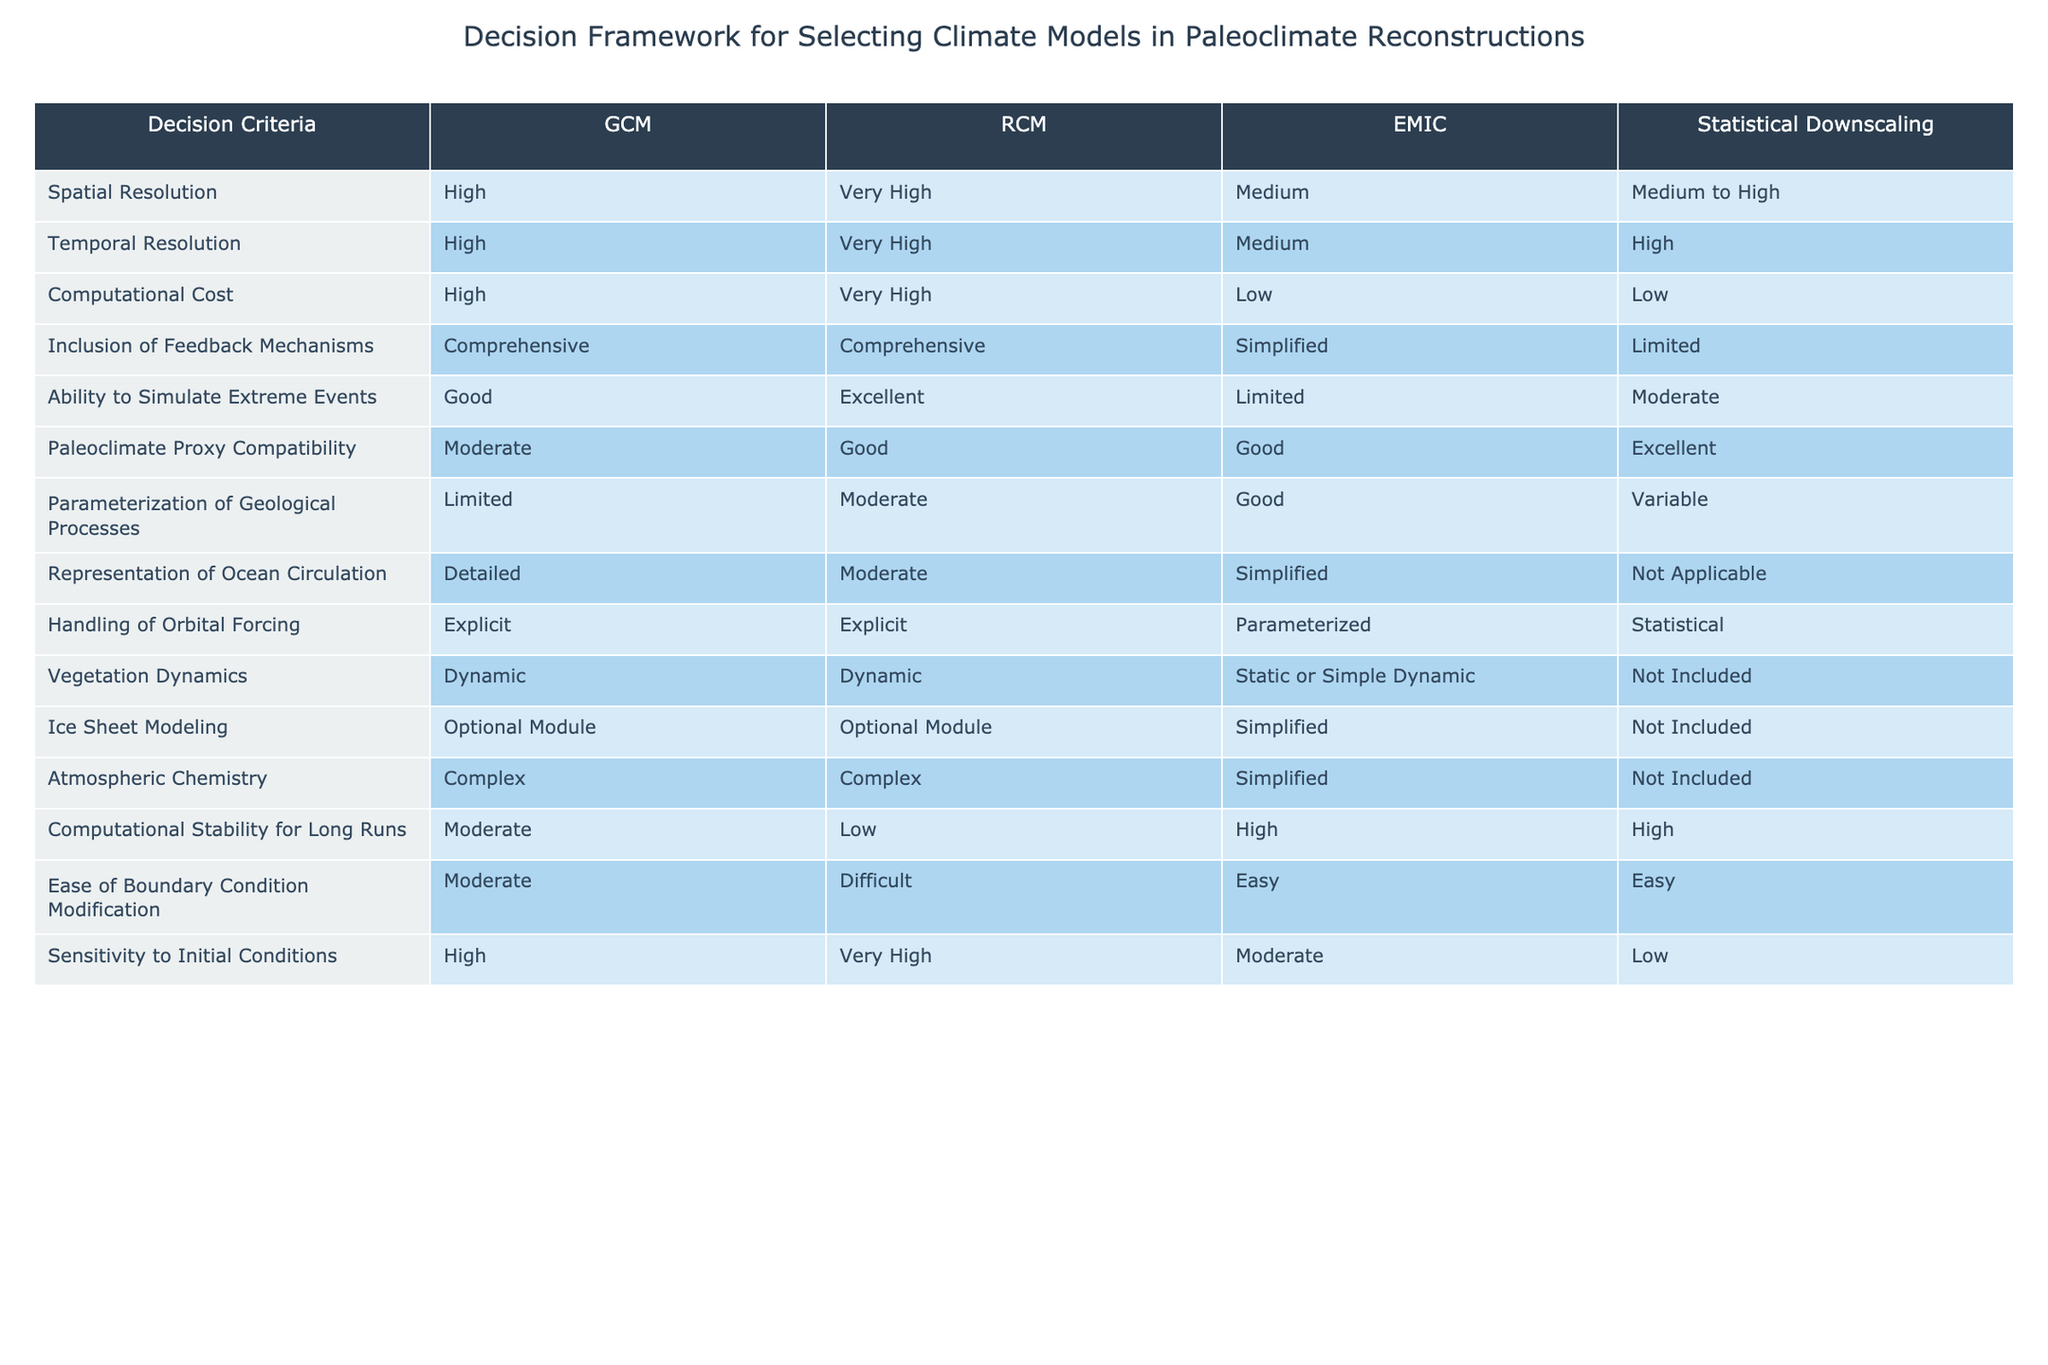What is the spatial resolution of GCM? The spatial resolution for GCM is listed directly in the table under the "Spatial Resolution" column. It states "High" for GCM.
Answer: High Which model has the highest temporal resolution? The table shows that RCM has "Very High" listed under the "Temporal Resolution" column, which is higher than all other models listed.
Answer: RCM Is the ability to simulate extreme events greater for RCM or GCM? The table shows that RCM has "Excellent" ability to simulate extreme events, while GCM has "Good." Therefore, RCM's capability is greater than that of GCM.
Answer: RCM What is the average computational stability for GCM and EMIC models? The computational stability for GCM is "Moderate," and for EMIC it is "High." To find the average, we can assign values, e.g., 2 for Moderate and 3 for High, which gives (2 + 3) / 2 = 2.5. Thus, the average stability rating is approximately 2.5, so we can classify it as between Moderate and High.
Answer: Between Moderate and High Does any model have limited parameterization of geological processes? The table indicates that both GCM and RCM have "Limited" and "Moderate" parameterization of geological processes, respectively, meaning GCM is indeed limited in this aspect.
Answer: Yes For handling orbital forcing, which models have an explicit approach? The table shows that both GCM and RCM handle orbital forcing with an "Explicit" method, whereas EMIC uses a "Parameterized" method and Statistical Downscaling uses a "Statistical" approach. Therefore, GCM and RCM are the two models that handle it explicitly.
Answer: GCM and RCM Which model is the most compatible with paleoclimate proxies? According to the table, Statistical Downscaling has "Excellent" compatibility with paleoclimate proxies, which is the highest listed in that category, while RCM has "Good" and GCM has "Moderate."
Answer: Statistical Downscaling How does the computational cost of EMIC compare to RCM? The table indicates that the computational cost of EMIC is "Low" while RCM is "Very High." Thus, EMIC has a significantly lower computational cost compared to RCM.
Answer: Lower Which model includes dynamic vegetation dynamics? The table states that both GCM and RCM include "Dynamic" vegetation dynamics, while EMIC states "Static or Simple Dynamic" and Statistical Downscaling states "Not Included."
Answer: GCM and RCM 